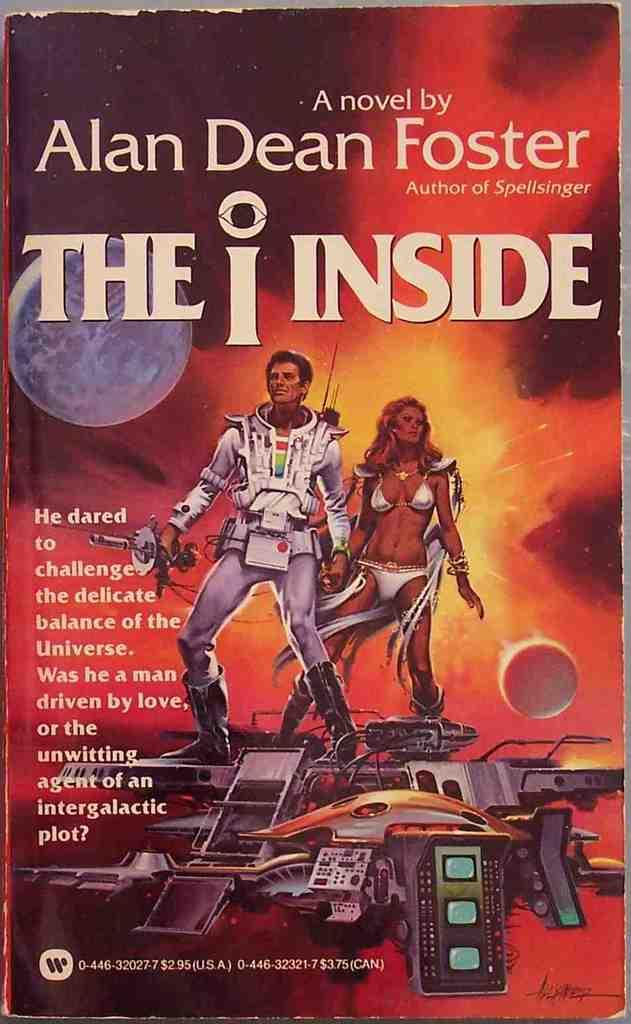<image>
Provide a brief description of the given image. The book The I Inside, By Alan Dean Foster. 